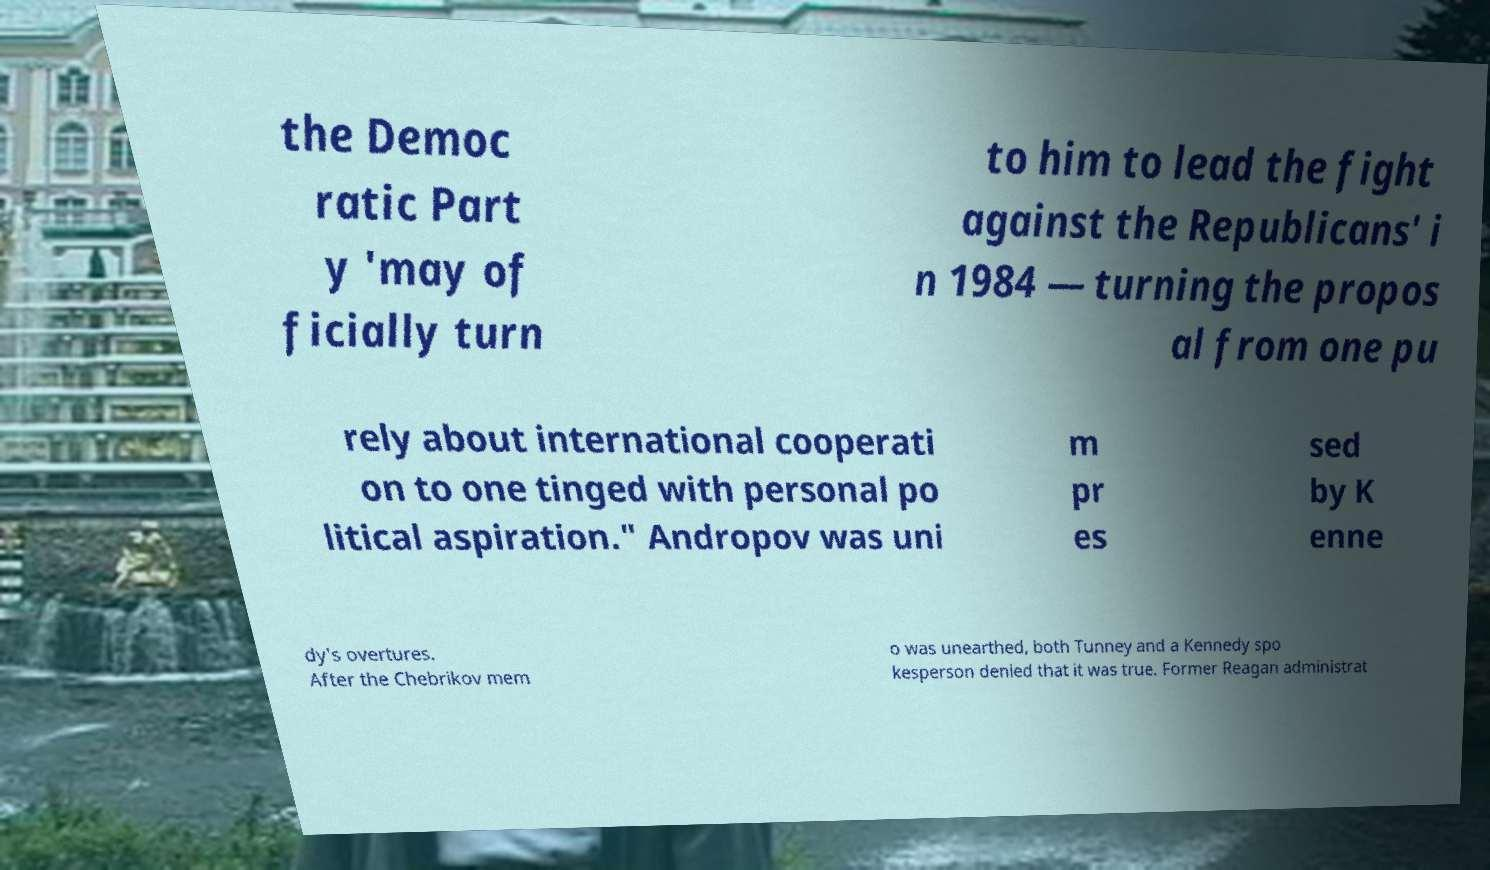I need the written content from this picture converted into text. Can you do that? the Democ ratic Part y 'may of ficially turn to him to lead the fight against the Republicans' i n 1984 — turning the propos al from one pu rely about international cooperati on to one tinged with personal po litical aspiration." Andropov was uni m pr es sed by K enne dy's overtures. After the Chebrikov mem o was unearthed, both Tunney and a Kennedy spo kesperson denied that it was true. Former Reagan administrat 